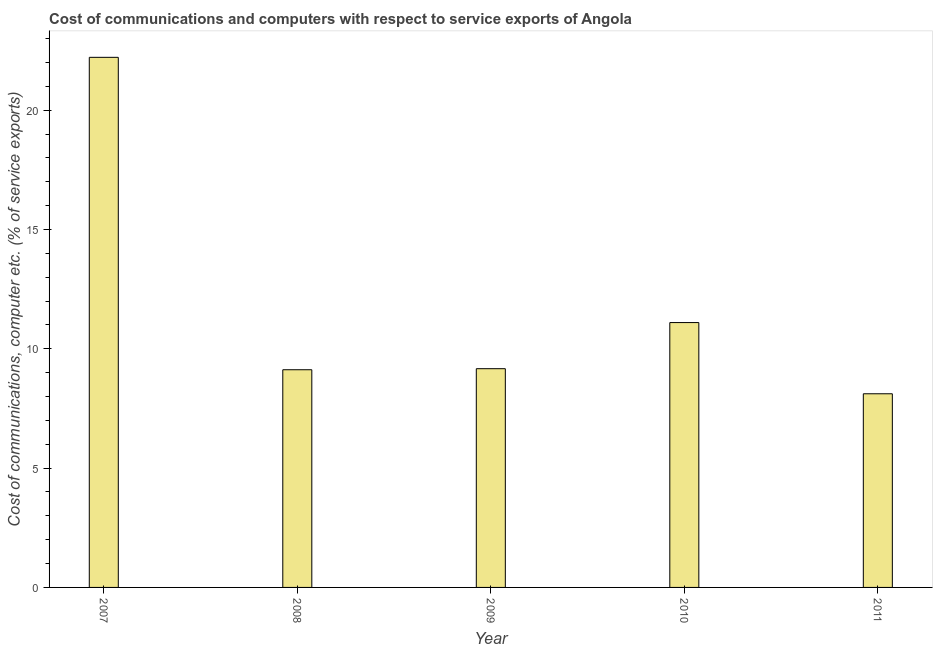What is the title of the graph?
Keep it short and to the point. Cost of communications and computers with respect to service exports of Angola. What is the label or title of the Y-axis?
Provide a short and direct response. Cost of communications, computer etc. (% of service exports). What is the cost of communications and computer in 2011?
Keep it short and to the point. 8.11. Across all years, what is the maximum cost of communications and computer?
Provide a succinct answer. 22.21. Across all years, what is the minimum cost of communications and computer?
Offer a terse response. 8.11. In which year was the cost of communications and computer maximum?
Your response must be concise. 2007. What is the sum of the cost of communications and computer?
Your answer should be compact. 59.71. What is the difference between the cost of communications and computer in 2009 and 2010?
Provide a short and direct response. -1.93. What is the average cost of communications and computer per year?
Your answer should be very brief. 11.94. What is the median cost of communications and computer?
Provide a succinct answer. 9.17. In how many years, is the cost of communications and computer greater than 6 %?
Provide a succinct answer. 5. What is the ratio of the cost of communications and computer in 2010 to that in 2011?
Your answer should be very brief. 1.37. Is the cost of communications and computer in 2007 less than that in 2009?
Offer a very short reply. No. Is the difference between the cost of communications and computer in 2007 and 2008 greater than the difference between any two years?
Offer a very short reply. No. What is the difference between the highest and the second highest cost of communications and computer?
Provide a succinct answer. 11.12. Is the sum of the cost of communications and computer in 2007 and 2008 greater than the maximum cost of communications and computer across all years?
Your answer should be compact. Yes. What is the difference between the highest and the lowest cost of communications and computer?
Your response must be concise. 14.1. In how many years, is the cost of communications and computer greater than the average cost of communications and computer taken over all years?
Offer a very short reply. 1. How many bars are there?
Keep it short and to the point. 5. Are all the bars in the graph horizontal?
Offer a terse response. No. What is the Cost of communications, computer etc. (% of service exports) of 2007?
Your answer should be compact. 22.21. What is the Cost of communications, computer etc. (% of service exports) of 2008?
Your answer should be compact. 9.12. What is the Cost of communications, computer etc. (% of service exports) in 2009?
Your answer should be very brief. 9.17. What is the Cost of communications, computer etc. (% of service exports) in 2010?
Ensure brevity in your answer.  11.1. What is the Cost of communications, computer etc. (% of service exports) in 2011?
Your answer should be compact. 8.11. What is the difference between the Cost of communications, computer etc. (% of service exports) in 2007 and 2008?
Provide a short and direct response. 13.09. What is the difference between the Cost of communications, computer etc. (% of service exports) in 2007 and 2009?
Make the answer very short. 13.05. What is the difference between the Cost of communications, computer etc. (% of service exports) in 2007 and 2010?
Your response must be concise. 11.11. What is the difference between the Cost of communications, computer etc. (% of service exports) in 2007 and 2011?
Keep it short and to the point. 14.1. What is the difference between the Cost of communications, computer etc. (% of service exports) in 2008 and 2009?
Your answer should be compact. -0.04. What is the difference between the Cost of communications, computer etc. (% of service exports) in 2008 and 2010?
Provide a succinct answer. -1.98. What is the difference between the Cost of communications, computer etc. (% of service exports) in 2008 and 2011?
Offer a very short reply. 1.01. What is the difference between the Cost of communications, computer etc. (% of service exports) in 2009 and 2010?
Ensure brevity in your answer.  -1.93. What is the difference between the Cost of communications, computer etc. (% of service exports) in 2009 and 2011?
Provide a succinct answer. 1.05. What is the difference between the Cost of communications, computer etc. (% of service exports) in 2010 and 2011?
Your answer should be very brief. 2.98. What is the ratio of the Cost of communications, computer etc. (% of service exports) in 2007 to that in 2008?
Your answer should be very brief. 2.44. What is the ratio of the Cost of communications, computer etc. (% of service exports) in 2007 to that in 2009?
Make the answer very short. 2.42. What is the ratio of the Cost of communications, computer etc. (% of service exports) in 2007 to that in 2010?
Your answer should be compact. 2. What is the ratio of the Cost of communications, computer etc. (% of service exports) in 2007 to that in 2011?
Give a very brief answer. 2.74. What is the ratio of the Cost of communications, computer etc. (% of service exports) in 2008 to that in 2009?
Ensure brevity in your answer.  0.99. What is the ratio of the Cost of communications, computer etc. (% of service exports) in 2008 to that in 2010?
Give a very brief answer. 0.82. What is the ratio of the Cost of communications, computer etc. (% of service exports) in 2008 to that in 2011?
Your answer should be very brief. 1.12. What is the ratio of the Cost of communications, computer etc. (% of service exports) in 2009 to that in 2010?
Provide a short and direct response. 0.83. What is the ratio of the Cost of communications, computer etc. (% of service exports) in 2009 to that in 2011?
Your answer should be compact. 1.13. What is the ratio of the Cost of communications, computer etc. (% of service exports) in 2010 to that in 2011?
Provide a short and direct response. 1.37. 